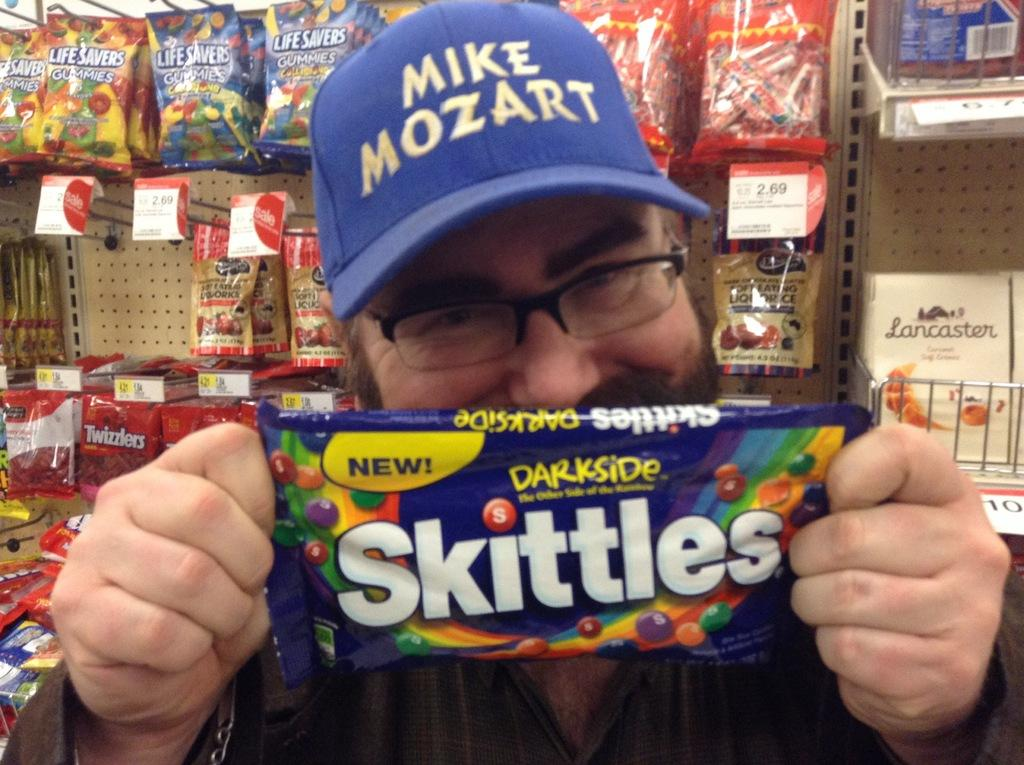What is the main subject in the foreground of the image? There is a man in the foreground of the image. What is the man holding in the image? The man is holding a snack packet. Can you describe the background of the image? There are other snack packets visible in the background of the image. What type of camera is the man using to take a picture in the image? There is no camera present in the image, and the man is not taking a picture. 